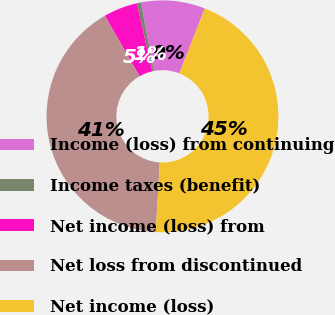Convert chart to OTSL. <chart><loc_0><loc_0><loc_500><loc_500><pie_chart><fcel>Income (loss) from continuing<fcel>Income taxes (benefit)<fcel>Net income (loss) from<fcel>Net loss from discontinued<fcel>Net income (loss)<nl><fcel>8.93%<fcel>0.56%<fcel>4.75%<fcel>40.79%<fcel>44.97%<nl></chart> 